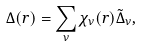Convert formula to latex. <formula><loc_0><loc_0><loc_500><loc_500>\Delta ( { r } ) = \sum _ { \nu } \chi _ { \nu } ( { r } ) \tilde { \Delta } _ { \nu } ,</formula> 